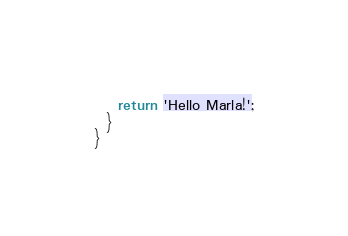Convert code to text. <code><loc_0><loc_0><loc_500><loc_500><_TypeScript_>    return 'Hello Marla!';
  }
}
</code> 